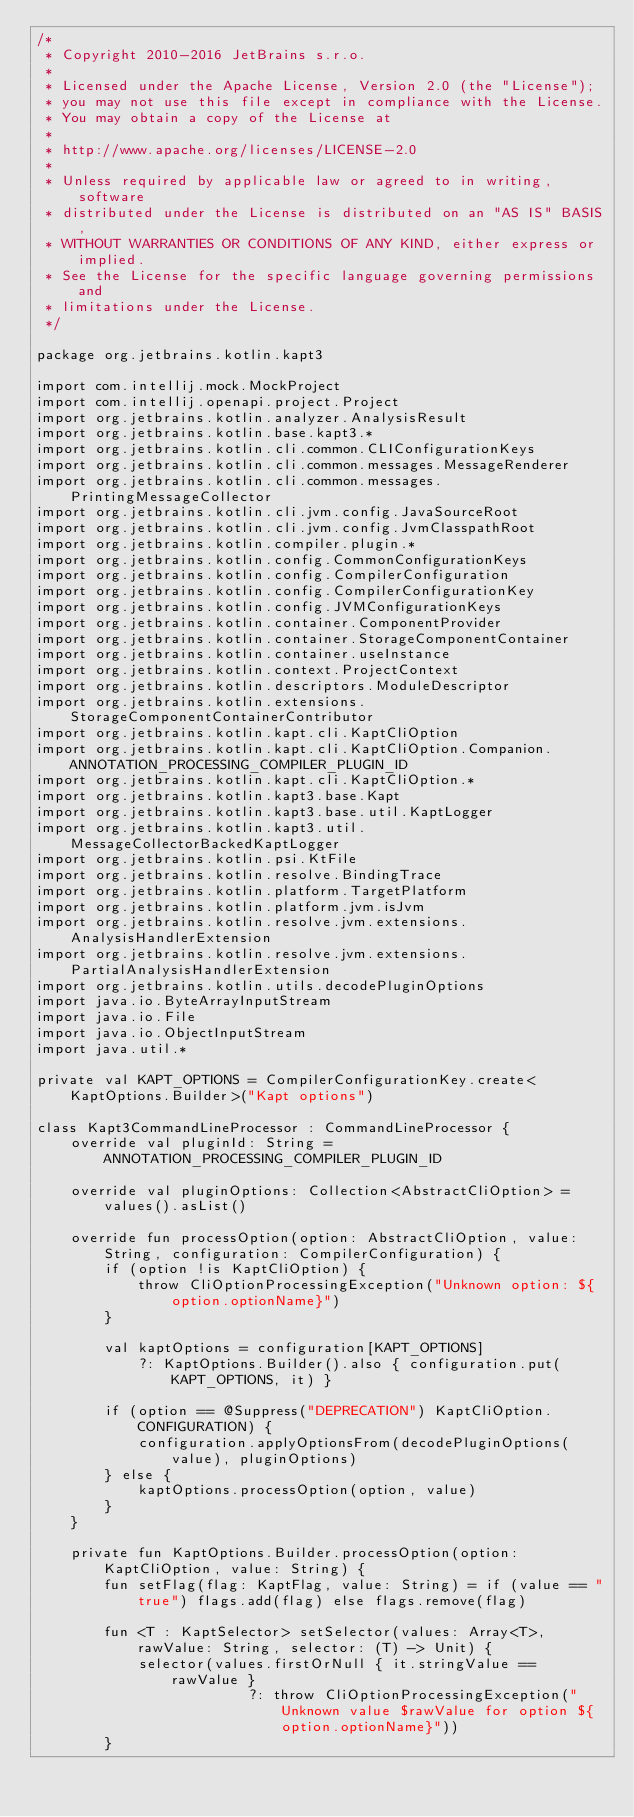<code> <loc_0><loc_0><loc_500><loc_500><_Kotlin_>/*
 * Copyright 2010-2016 JetBrains s.r.o.
 *
 * Licensed under the Apache License, Version 2.0 (the "License");
 * you may not use this file except in compliance with the License.
 * You may obtain a copy of the License at
 *
 * http://www.apache.org/licenses/LICENSE-2.0
 *
 * Unless required by applicable law or agreed to in writing, software
 * distributed under the License is distributed on an "AS IS" BASIS,
 * WITHOUT WARRANTIES OR CONDITIONS OF ANY KIND, either express or implied.
 * See the License for the specific language governing permissions and
 * limitations under the License.
 */

package org.jetbrains.kotlin.kapt3

import com.intellij.mock.MockProject
import com.intellij.openapi.project.Project
import org.jetbrains.kotlin.analyzer.AnalysisResult
import org.jetbrains.kotlin.base.kapt3.*
import org.jetbrains.kotlin.cli.common.CLIConfigurationKeys
import org.jetbrains.kotlin.cli.common.messages.MessageRenderer
import org.jetbrains.kotlin.cli.common.messages.PrintingMessageCollector
import org.jetbrains.kotlin.cli.jvm.config.JavaSourceRoot
import org.jetbrains.kotlin.cli.jvm.config.JvmClasspathRoot
import org.jetbrains.kotlin.compiler.plugin.*
import org.jetbrains.kotlin.config.CommonConfigurationKeys
import org.jetbrains.kotlin.config.CompilerConfiguration
import org.jetbrains.kotlin.config.CompilerConfigurationKey
import org.jetbrains.kotlin.config.JVMConfigurationKeys
import org.jetbrains.kotlin.container.ComponentProvider
import org.jetbrains.kotlin.container.StorageComponentContainer
import org.jetbrains.kotlin.container.useInstance
import org.jetbrains.kotlin.context.ProjectContext
import org.jetbrains.kotlin.descriptors.ModuleDescriptor
import org.jetbrains.kotlin.extensions.StorageComponentContainerContributor
import org.jetbrains.kotlin.kapt.cli.KaptCliOption
import org.jetbrains.kotlin.kapt.cli.KaptCliOption.Companion.ANNOTATION_PROCESSING_COMPILER_PLUGIN_ID
import org.jetbrains.kotlin.kapt.cli.KaptCliOption.*
import org.jetbrains.kotlin.kapt3.base.Kapt
import org.jetbrains.kotlin.kapt3.base.util.KaptLogger
import org.jetbrains.kotlin.kapt3.util.MessageCollectorBackedKaptLogger
import org.jetbrains.kotlin.psi.KtFile
import org.jetbrains.kotlin.resolve.BindingTrace
import org.jetbrains.kotlin.platform.TargetPlatform
import org.jetbrains.kotlin.platform.jvm.isJvm
import org.jetbrains.kotlin.resolve.jvm.extensions.AnalysisHandlerExtension
import org.jetbrains.kotlin.resolve.jvm.extensions.PartialAnalysisHandlerExtension
import org.jetbrains.kotlin.utils.decodePluginOptions
import java.io.ByteArrayInputStream
import java.io.File
import java.io.ObjectInputStream
import java.util.*

private val KAPT_OPTIONS = CompilerConfigurationKey.create<KaptOptions.Builder>("Kapt options")

class Kapt3CommandLineProcessor : CommandLineProcessor {
    override val pluginId: String = ANNOTATION_PROCESSING_COMPILER_PLUGIN_ID

    override val pluginOptions: Collection<AbstractCliOption> = values().asList()

    override fun processOption(option: AbstractCliOption, value: String, configuration: CompilerConfiguration) {
        if (option !is KaptCliOption) {
            throw CliOptionProcessingException("Unknown option: ${option.optionName}")
        }

        val kaptOptions = configuration[KAPT_OPTIONS]
            ?: KaptOptions.Builder().also { configuration.put(KAPT_OPTIONS, it) }

        if (option == @Suppress("DEPRECATION") KaptCliOption.CONFIGURATION) {
            configuration.applyOptionsFrom(decodePluginOptions(value), pluginOptions)
        } else {
            kaptOptions.processOption(option, value)
        }
    }

    private fun KaptOptions.Builder.processOption(option: KaptCliOption, value: String) {
        fun setFlag(flag: KaptFlag, value: String) = if (value == "true") flags.add(flag) else flags.remove(flag)

        fun <T : KaptSelector> setSelector(values: Array<T>, rawValue: String, selector: (T) -> Unit) {
            selector(values.firstOrNull { it.stringValue == rawValue }
                         ?: throw CliOptionProcessingException("Unknown value $rawValue for option ${option.optionName}"))
        }
</code> 